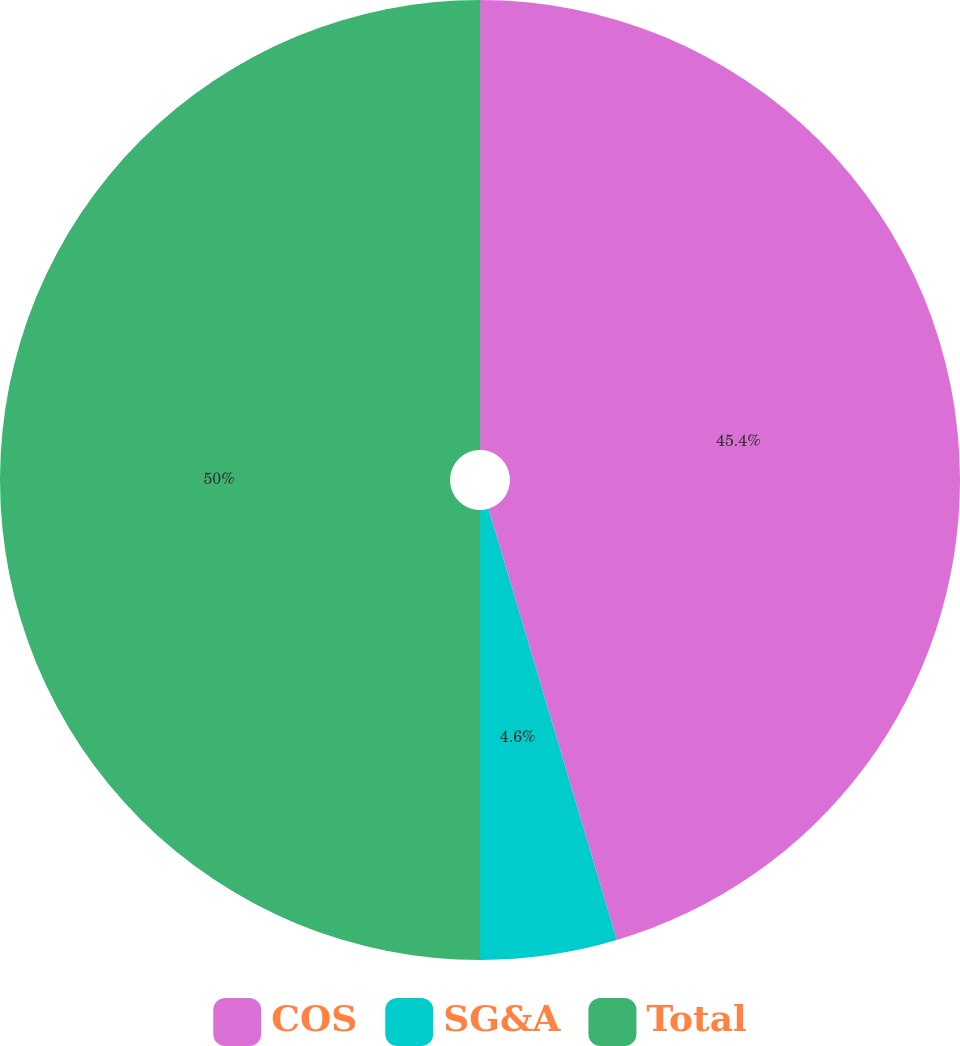<chart> <loc_0><loc_0><loc_500><loc_500><pie_chart><fcel>COS<fcel>SG&A<fcel>Total<nl><fcel>45.4%<fcel>4.6%<fcel>50.0%<nl></chart> 